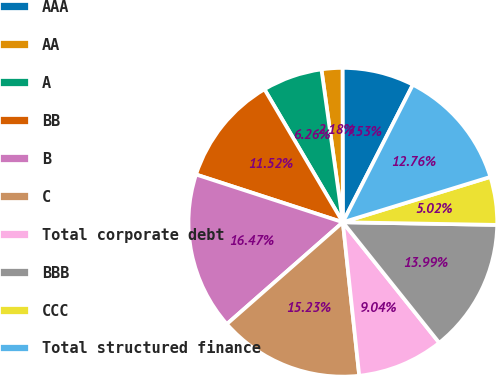Convert chart to OTSL. <chart><loc_0><loc_0><loc_500><loc_500><pie_chart><fcel>AAA<fcel>AA<fcel>A<fcel>BB<fcel>B<fcel>C<fcel>Total corporate debt<fcel>BBB<fcel>CCC<fcel>Total structured finance<nl><fcel>7.53%<fcel>2.18%<fcel>6.26%<fcel>11.52%<fcel>16.47%<fcel>15.23%<fcel>9.04%<fcel>13.99%<fcel>5.02%<fcel>12.76%<nl></chart> 